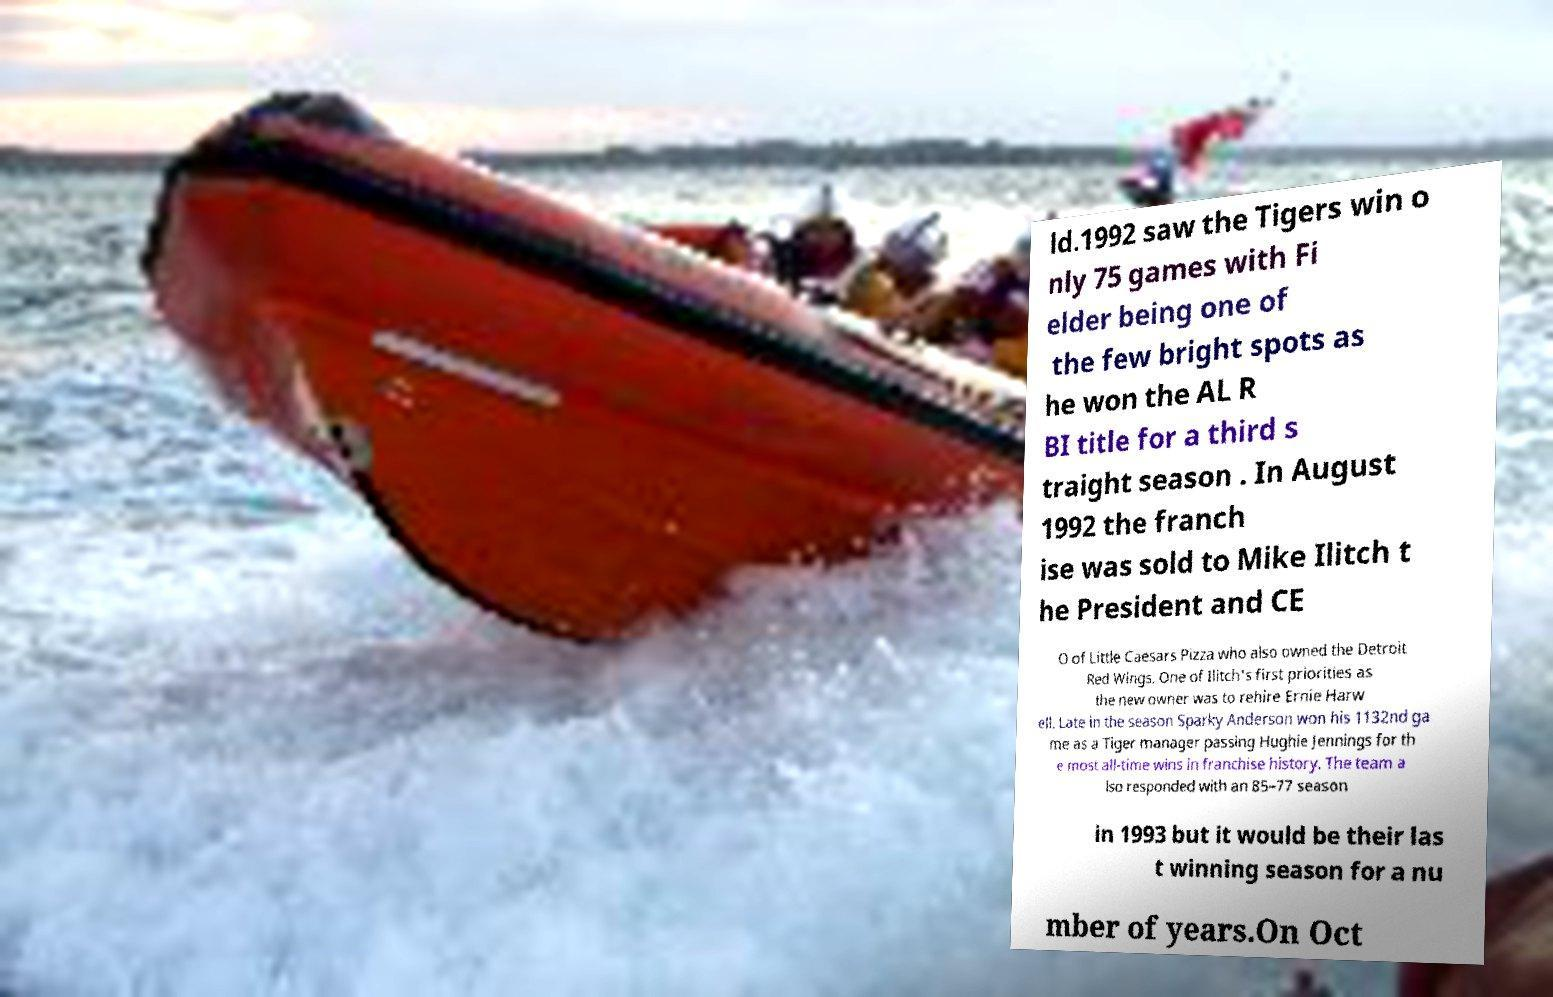Please read and relay the text visible in this image. What does it say? ld.1992 saw the Tigers win o nly 75 games with Fi elder being one of the few bright spots as he won the AL R BI title for a third s traight season . In August 1992 the franch ise was sold to Mike Ilitch t he President and CE O of Little Caesars Pizza who also owned the Detroit Red Wings. One of Ilitch's first priorities as the new owner was to rehire Ernie Harw ell. Late in the season Sparky Anderson won his 1132nd ga me as a Tiger manager passing Hughie Jennings for th e most all-time wins in franchise history. The team a lso responded with an 85–77 season in 1993 but it would be their las t winning season for a nu mber of years.On Oct 